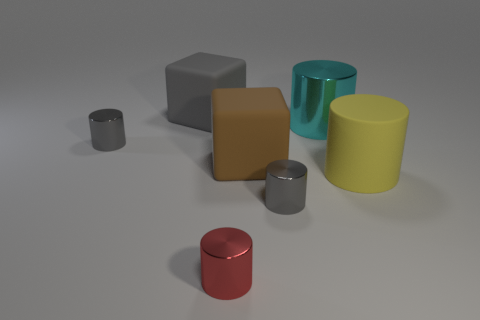How do the textures of the different cylinders compare? The cylinders exhibit a variety of textures. The one with a cyan color has a smooth and reflective finish, suggesting it is a polished surface. On the contrary, the yellow cylinder appears to have a matte texture that diffuses light, giving it a non-reflective appearance. 